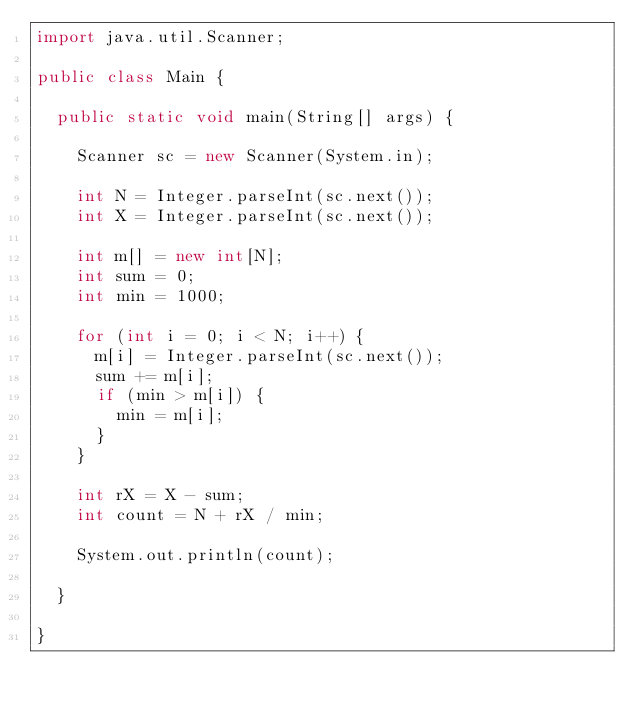Convert code to text. <code><loc_0><loc_0><loc_500><loc_500><_Java_>import java.util.Scanner;

public class Main {

  public static void main(String[] args) {

    Scanner sc = new Scanner(System.in);

    int N = Integer.parseInt(sc.next());
    int X = Integer.parseInt(sc.next());

    int m[] = new int[N];
    int sum = 0;
    int min = 1000;

    for (int i = 0; i < N; i++) {
      m[i] = Integer.parseInt(sc.next());
      sum += m[i];
      if (min > m[i]) {
        min = m[i];
      }
    }

    int rX = X - sum;
    int count = N + rX / min;

    System.out.println(count);

  }

}</code> 